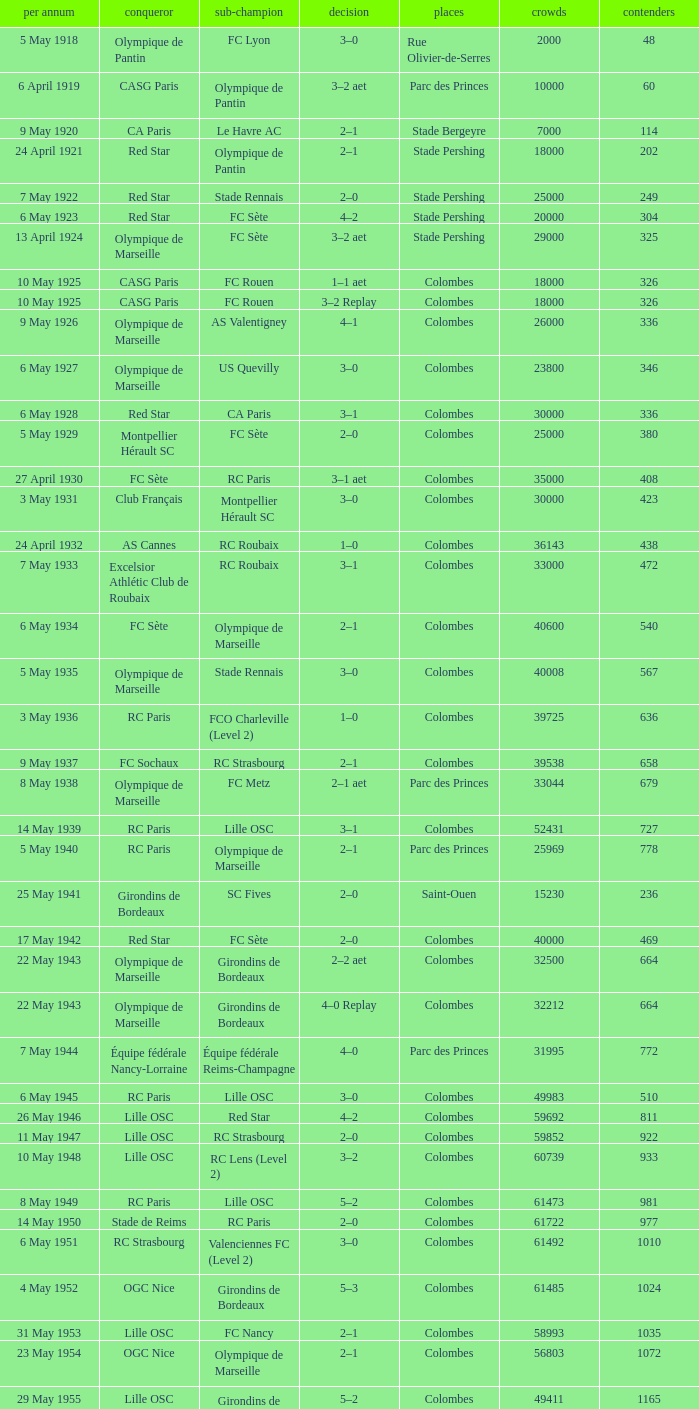How many games had red star as the runner up? 1.0. 